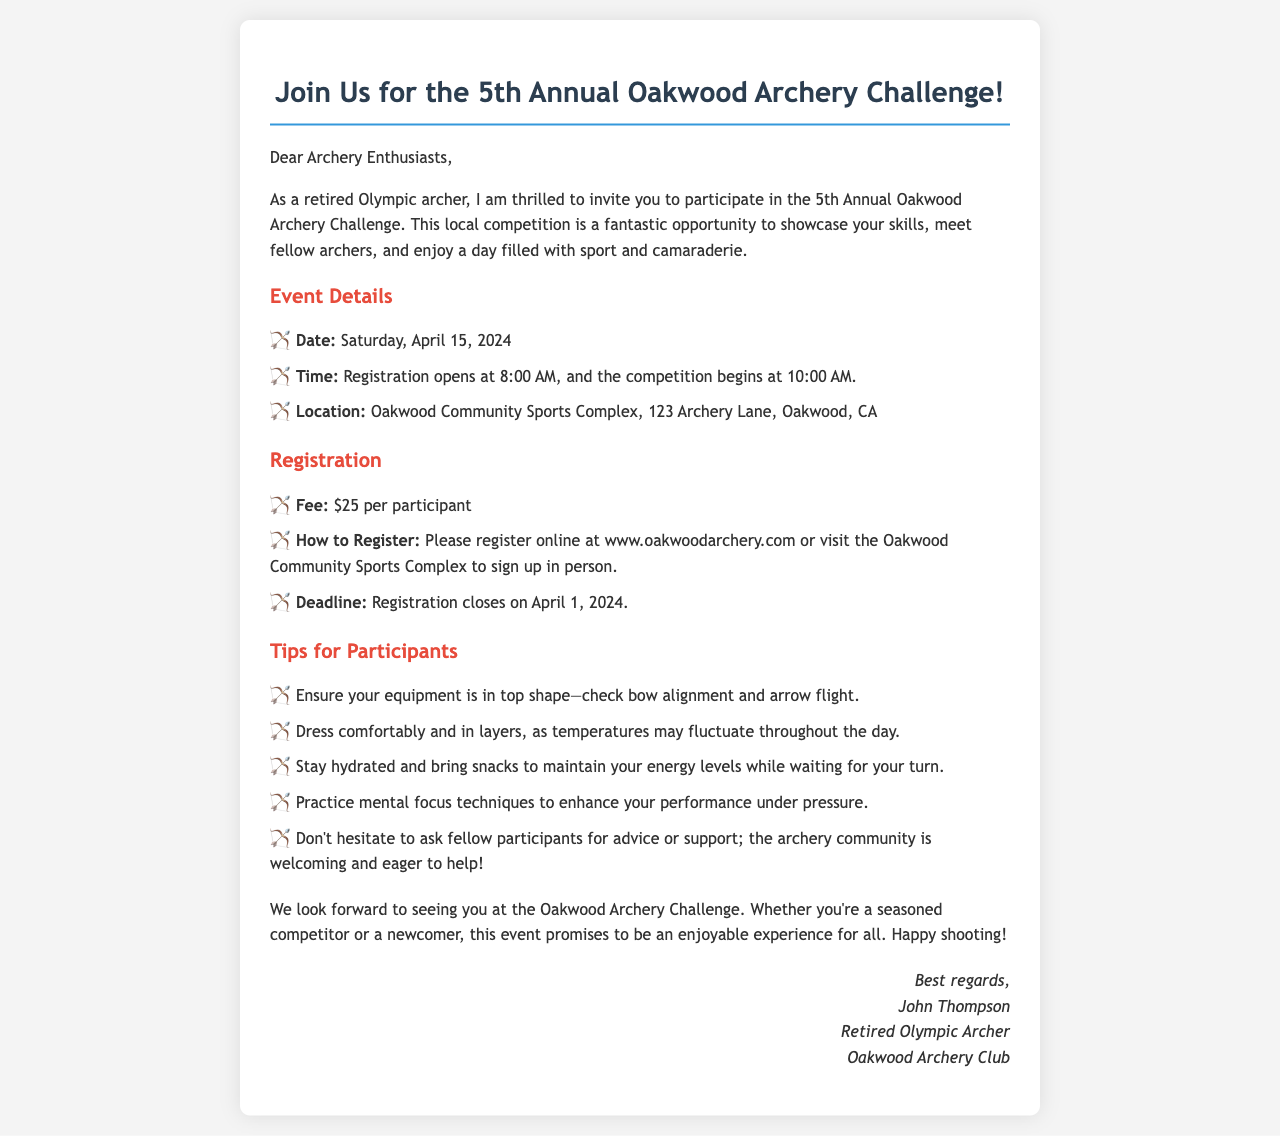What is the event date? The event date is clearly stated in the document as Saturday, April 15, 2024.
Answer: Saturday, April 15, 2024 What time does registration open? The document specifies that registration opens at 8:00 AM.
Answer: 8:00 AM Where is the competition taking place? The location for the event is mentioned as Oakwood Community Sports Complex, 123 Archery Lane, Oakwood, CA.
Answer: Oakwood Community Sports Complex, 123 Archery Lane, Oakwood, CA What is the registration fee? The registration fee is listed as $25 per participant in the document.
Answer: $25 When does registration close? The document states that the registration deadline is April 1, 2024.
Answer: April 1, 2024 What should participants bring to maintain energy levels? The document suggests participants bring snacks to maintain their energy levels while waiting.
Answer: Snacks What does the event promise for participants? The document mentions that the event promises to be an enjoyable experience for all participants.
Answer: An enjoyable experience What is the primary purpose of the invitation? The invitation aims to invite participants to showcase their skills and meet fellow archers.
Answer: Showcase skills and meet fellow archers Who is the author of the invitation? The invitation is signed by John Thompson, a retired Olympic archer.
Answer: John Thompson 